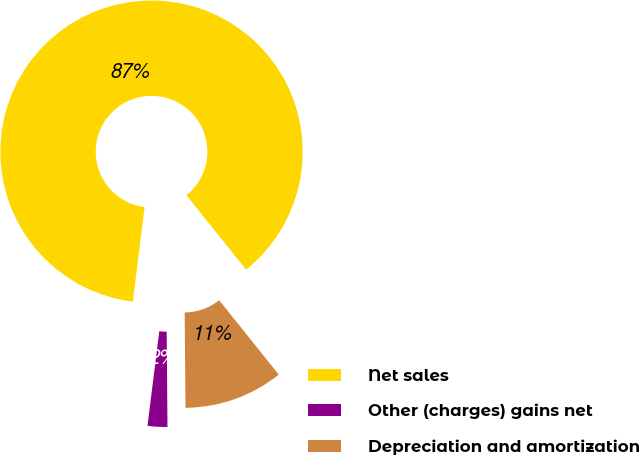Convert chart. <chart><loc_0><loc_0><loc_500><loc_500><pie_chart><fcel>Net sales<fcel>Other (charges) gains net<fcel>Depreciation and amortization<nl><fcel>87.27%<fcel>2.11%<fcel>10.62%<nl></chart> 